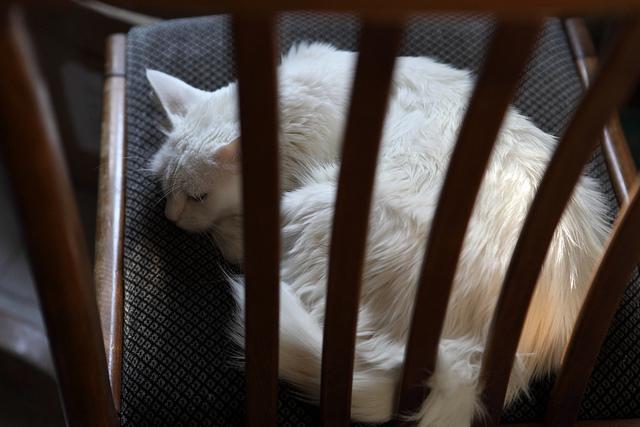Is the cat playing?
Be succinct. No. Where is the photographer standing?
Quick response, please. Behind chair. Do you think this is a beautiful cat?
Short answer required. Yes. 